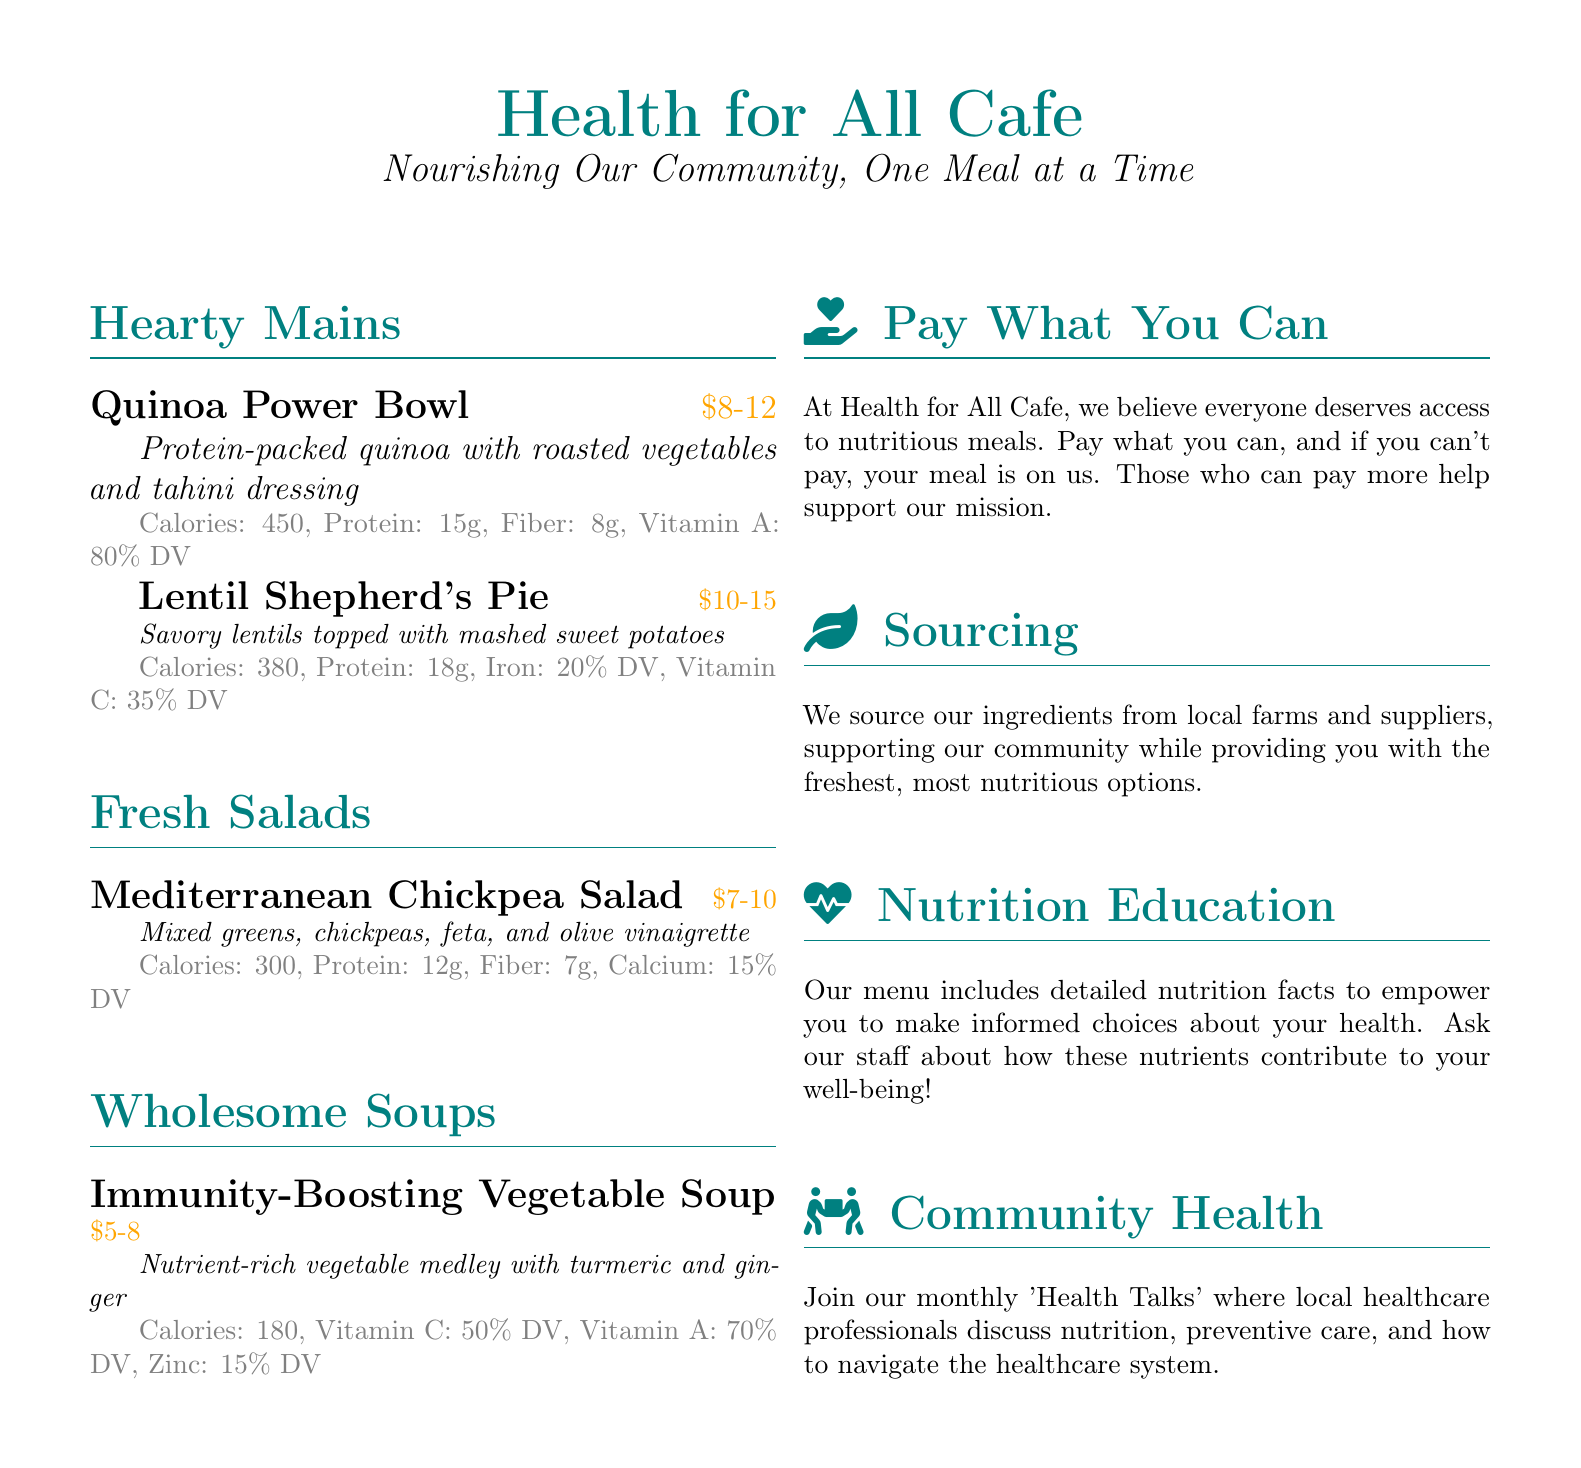What is the first dish listed under Hearty Mains? The first dish listed is the Quinoa Power Bowl.
Answer: Quinoa Power Bowl How many grams of protein are in the Lentil Shepherd's Pie? The Lentil Shepherd's Pie contains 18 grams of protein.
Answer: 18g What is the price range for the Mediterranean Chickpea Salad? The price range for the Mediterranean Chickpea Salad is between $7 and $10.
Answer: $7-10 What vitamin's daily value is provided by the Immunity-Boosting Vegetable Soup? The Immunity-Boosting Vegetable Soup provides 50% of the daily value for Vitamin C.
Answer: Vitamin C What community event is mentioned in the menu? The menu mentions a monthly 'Health Talks' event.
Answer: Health Talks Which ingredient adds iron content to the Lentil Shepherd's Pie? The ingredient that adds iron content is lentils.
Answer: Lentils What does the cafe believe everyone deserves access to? The cafe believes everyone deserves access to nutritious meals.
Answer: Nutritious meals What is the color theme used for the menu's title? The color theme used for the menu's title is teal, defined as maincolor.
Answer: Teal 